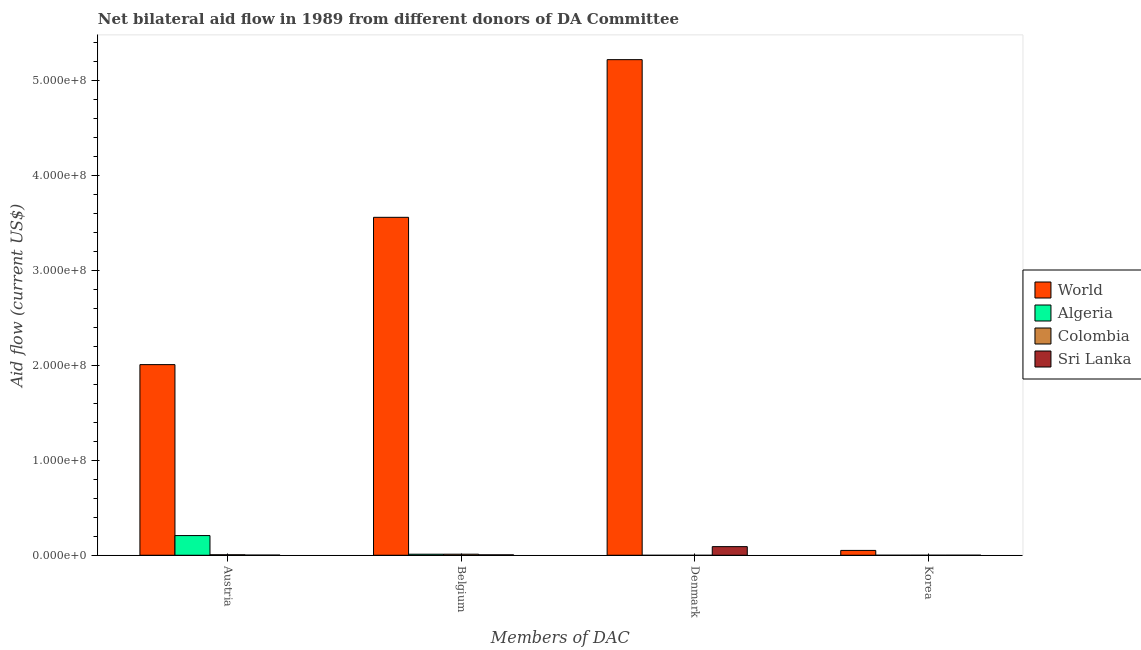How many groups of bars are there?
Offer a very short reply. 4. How many bars are there on the 2nd tick from the left?
Offer a terse response. 4. What is the label of the 4th group of bars from the left?
Make the answer very short. Korea. What is the amount of aid given by belgium in World?
Make the answer very short. 3.56e+08. Across all countries, what is the maximum amount of aid given by denmark?
Provide a short and direct response. 5.22e+08. Across all countries, what is the minimum amount of aid given by belgium?
Offer a terse response. 4.50e+05. In which country was the amount of aid given by denmark maximum?
Your answer should be very brief. World. What is the total amount of aid given by korea in the graph?
Your answer should be very brief. 5.18e+06. What is the difference between the amount of aid given by belgium in World and that in Sri Lanka?
Your answer should be very brief. 3.56e+08. What is the difference between the amount of aid given by korea in World and the amount of aid given by belgium in Colombia?
Make the answer very short. 3.98e+06. What is the average amount of aid given by belgium per country?
Give a very brief answer. 8.97e+07. What is the difference between the amount of aid given by korea and amount of aid given by austria in Algeria?
Provide a short and direct response. -2.07e+07. In how many countries, is the amount of aid given by denmark greater than 80000000 US$?
Your response must be concise. 1. What is the ratio of the amount of aid given by belgium in Algeria to that in Colombia?
Keep it short and to the point. 0.98. What is the difference between the highest and the second highest amount of aid given by austria?
Provide a succinct answer. 1.80e+08. What is the difference between the highest and the lowest amount of aid given by belgium?
Offer a very short reply. 3.56e+08. Is it the case that in every country, the sum of the amount of aid given by belgium and amount of aid given by austria is greater than the sum of amount of aid given by denmark and amount of aid given by korea?
Keep it short and to the point. No. Is it the case that in every country, the sum of the amount of aid given by austria and amount of aid given by belgium is greater than the amount of aid given by denmark?
Provide a short and direct response. No. Are all the bars in the graph horizontal?
Give a very brief answer. No. How are the legend labels stacked?
Provide a short and direct response. Vertical. What is the title of the graph?
Your answer should be compact. Net bilateral aid flow in 1989 from different donors of DA Committee. Does "Ecuador" appear as one of the legend labels in the graph?
Give a very brief answer. No. What is the label or title of the X-axis?
Offer a very short reply. Members of DAC. What is the Aid flow (current US$) of World in Austria?
Ensure brevity in your answer.  2.01e+08. What is the Aid flow (current US$) in Algeria in Austria?
Offer a terse response. 2.08e+07. What is the Aid flow (current US$) of Colombia in Austria?
Offer a very short reply. 5.30e+05. What is the Aid flow (current US$) in World in Belgium?
Offer a terse response. 3.56e+08. What is the Aid flow (current US$) in Algeria in Belgium?
Make the answer very short. 1.11e+06. What is the Aid flow (current US$) of Colombia in Belgium?
Your answer should be very brief. 1.13e+06. What is the Aid flow (current US$) in World in Denmark?
Ensure brevity in your answer.  5.22e+08. What is the Aid flow (current US$) of Sri Lanka in Denmark?
Make the answer very short. 9.10e+06. What is the Aid flow (current US$) in World in Korea?
Ensure brevity in your answer.  5.11e+06. Across all Members of DAC, what is the maximum Aid flow (current US$) of World?
Your answer should be very brief. 5.22e+08. Across all Members of DAC, what is the maximum Aid flow (current US$) of Algeria?
Offer a terse response. 2.08e+07. Across all Members of DAC, what is the maximum Aid flow (current US$) in Colombia?
Your answer should be very brief. 1.13e+06. Across all Members of DAC, what is the maximum Aid flow (current US$) in Sri Lanka?
Provide a succinct answer. 9.10e+06. Across all Members of DAC, what is the minimum Aid flow (current US$) of World?
Your answer should be compact. 5.11e+06. What is the total Aid flow (current US$) in World in the graph?
Your response must be concise. 1.08e+09. What is the total Aid flow (current US$) of Algeria in the graph?
Keep it short and to the point. 2.19e+07. What is the total Aid flow (current US$) in Colombia in the graph?
Offer a very short reply. 1.68e+06. What is the total Aid flow (current US$) in Sri Lanka in the graph?
Ensure brevity in your answer.  9.77e+06. What is the difference between the Aid flow (current US$) of World in Austria and that in Belgium?
Offer a very short reply. -1.55e+08. What is the difference between the Aid flow (current US$) of Algeria in Austria and that in Belgium?
Your answer should be compact. 1.96e+07. What is the difference between the Aid flow (current US$) of Colombia in Austria and that in Belgium?
Keep it short and to the point. -6.00e+05. What is the difference between the Aid flow (current US$) of World in Austria and that in Denmark?
Keep it short and to the point. -3.21e+08. What is the difference between the Aid flow (current US$) in Sri Lanka in Austria and that in Denmark?
Provide a short and direct response. -8.92e+06. What is the difference between the Aid flow (current US$) in World in Austria and that in Korea?
Offer a very short reply. 1.96e+08. What is the difference between the Aid flow (current US$) of Algeria in Austria and that in Korea?
Give a very brief answer. 2.07e+07. What is the difference between the Aid flow (current US$) in Colombia in Austria and that in Korea?
Give a very brief answer. 5.10e+05. What is the difference between the Aid flow (current US$) in World in Belgium and that in Denmark?
Your answer should be very brief. -1.66e+08. What is the difference between the Aid flow (current US$) of Sri Lanka in Belgium and that in Denmark?
Offer a terse response. -8.65e+06. What is the difference between the Aid flow (current US$) of World in Belgium and that in Korea?
Offer a terse response. 3.51e+08. What is the difference between the Aid flow (current US$) in Algeria in Belgium and that in Korea?
Your response must be concise. 1.10e+06. What is the difference between the Aid flow (current US$) in Colombia in Belgium and that in Korea?
Make the answer very short. 1.11e+06. What is the difference between the Aid flow (current US$) of World in Denmark and that in Korea?
Offer a terse response. 5.17e+08. What is the difference between the Aid flow (current US$) of Sri Lanka in Denmark and that in Korea?
Your answer should be very brief. 9.06e+06. What is the difference between the Aid flow (current US$) of World in Austria and the Aid flow (current US$) of Algeria in Belgium?
Offer a terse response. 2.00e+08. What is the difference between the Aid flow (current US$) of World in Austria and the Aid flow (current US$) of Colombia in Belgium?
Make the answer very short. 2.00e+08. What is the difference between the Aid flow (current US$) in World in Austria and the Aid flow (current US$) in Sri Lanka in Belgium?
Your response must be concise. 2.00e+08. What is the difference between the Aid flow (current US$) of Algeria in Austria and the Aid flow (current US$) of Colombia in Belgium?
Provide a succinct answer. 1.96e+07. What is the difference between the Aid flow (current US$) of Algeria in Austria and the Aid flow (current US$) of Sri Lanka in Belgium?
Offer a terse response. 2.03e+07. What is the difference between the Aid flow (current US$) in Colombia in Austria and the Aid flow (current US$) in Sri Lanka in Belgium?
Give a very brief answer. 8.00e+04. What is the difference between the Aid flow (current US$) in World in Austria and the Aid flow (current US$) in Sri Lanka in Denmark?
Your response must be concise. 1.92e+08. What is the difference between the Aid flow (current US$) in Algeria in Austria and the Aid flow (current US$) in Sri Lanka in Denmark?
Offer a terse response. 1.16e+07. What is the difference between the Aid flow (current US$) of Colombia in Austria and the Aid flow (current US$) of Sri Lanka in Denmark?
Offer a terse response. -8.57e+06. What is the difference between the Aid flow (current US$) of World in Austria and the Aid flow (current US$) of Algeria in Korea?
Make the answer very short. 2.01e+08. What is the difference between the Aid flow (current US$) in World in Austria and the Aid flow (current US$) in Colombia in Korea?
Provide a short and direct response. 2.01e+08. What is the difference between the Aid flow (current US$) in World in Austria and the Aid flow (current US$) in Sri Lanka in Korea?
Offer a terse response. 2.01e+08. What is the difference between the Aid flow (current US$) in Algeria in Austria and the Aid flow (current US$) in Colombia in Korea?
Provide a succinct answer. 2.07e+07. What is the difference between the Aid flow (current US$) in Algeria in Austria and the Aid flow (current US$) in Sri Lanka in Korea?
Your response must be concise. 2.07e+07. What is the difference between the Aid flow (current US$) in World in Belgium and the Aid flow (current US$) in Sri Lanka in Denmark?
Give a very brief answer. 3.47e+08. What is the difference between the Aid flow (current US$) in Algeria in Belgium and the Aid flow (current US$) in Sri Lanka in Denmark?
Make the answer very short. -7.99e+06. What is the difference between the Aid flow (current US$) of Colombia in Belgium and the Aid flow (current US$) of Sri Lanka in Denmark?
Offer a very short reply. -7.97e+06. What is the difference between the Aid flow (current US$) of World in Belgium and the Aid flow (current US$) of Algeria in Korea?
Keep it short and to the point. 3.56e+08. What is the difference between the Aid flow (current US$) in World in Belgium and the Aid flow (current US$) in Colombia in Korea?
Make the answer very short. 3.56e+08. What is the difference between the Aid flow (current US$) in World in Belgium and the Aid flow (current US$) in Sri Lanka in Korea?
Your answer should be compact. 3.56e+08. What is the difference between the Aid flow (current US$) in Algeria in Belgium and the Aid flow (current US$) in Colombia in Korea?
Give a very brief answer. 1.09e+06. What is the difference between the Aid flow (current US$) of Algeria in Belgium and the Aid flow (current US$) of Sri Lanka in Korea?
Ensure brevity in your answer.  1.07e+06. What is the difference between the Aid flow (current US$) of Colombia in Belgium and the Aid flow (current US$) of Sri Lanka in Korea?
Your response must be concise. 1.09e+06. What is the difference between the Aid flow (current US$) in World in Denmark and the Aid flow (current US$) in Algeria in Korea?
Your answer should be compact. 5.22e+08. What is the difference between the Aid flow (current US$) of World in Denmark and the Aid flow (current US$) of Colombia in Korea?
Your response must be concise. 5.22e+08. What is the difference between the Aid flow (current US$) in World in Denmark and the Aid flow (current US$) in Sri Lanka in Korea?
Make the answer very short. 5.22e+08. What is the average Aid flow (current US$) in World per Members of DAC?
Give a very brief answer. 2.71e+08. What is the average Aid flow (current US$) in Algeria per Members of DAC?
Your answer should be very brief. 5.47e+06. What is the average Aid flow (current US$) of Colombia per Members of DAC?
Your answer should be compact. 4.20e+05. What is the average Aid flow (current US$) in Sri Lanka per Members of DAC?
Offer a very short reply. 2.44e+06. What is the difference between the Aid flow (current US$) in World and Aid flow (current US$) in Algeria in Austria?
Offer a very short reply. 1.80e+08. What is the difference between the Aid flow (current US$) of World and Aid flow (current US$) of Colombia in Austria?
Ensure brevity in your answer.  2.00e+08. What is the difference between the Aid flow (current US$) in World and Aid flow (current US$) in Sri Lanka in Austria?
Give a very brief answer. 2.01e+08. What is the difference between the Aid flow (current US$) of Algeria and Aid flow (current US$) of Colombia in Austria?
Your answer should be very brief. 2.02e+07. What is the difference between the Aid flow (current US$) of Algeria and Aid flow (current US$) of Sri Lanka in Austria?
Ensure brevity in your answer.  2.06e+07. What is the difference between the Aid flow (current US$) of World and Aid flow (current US$) of Algeria in Belgium?
Ensure brevity in your answer.  3.55e+08. What is the difference between the Aid flow (current US$) in World and Aid flow (current US$) in Colombia in Belgium?
Give a very brief answer. 3.55e+08. What is the difference between the Aid flow (current US$) in World and Aid flow (current US$) in Sri Lanka in Belgium?
Make the answer very short. 3.56e+08. What is the difference between the Aid flow (current US$) of Colombia and Aid flow (current US$) of Sri Lanka in Belgium?
Provide a short and direct response. 6.80e+05. What is the difference between the Aid flow (current US$) of World and Aid flow (current US$) of Sri Lanka in Denmark?
Give a very brief answer. 5.13e+08. What is the difference between the Aid flow (current US$) of World and Aid flow (current US$) of Algeria in Korea?
Make the answer very short. 5.10e+06. What is the difference between the Aid flow (current US$) of World and Aid flow (current US$) of Colombia in Korea?
Keep it short and to the point. 5.09e+06. What is the difference between the Aid flow (current US$) of World and Aid flow (current US$) of Sri Lanka in Korea?
Your response must be concise. 5.07e+06. What is the difference between the Aid flow (current US$) of Algeria and Aid flow (current US$) of Colombia in Korea?
Your answer should be compact. -10000. What is the ratio of the Aid flow (current US$) in World in Austria to that in Belgium?
Your answer should be very brief. 0.56. What is the ratio of the Aid flow (current US$) in Algeria in Austria to that in Belgium?
Provide a short and direct response. 18.69. What is the ratio of the Aid flow (current US$) in Colombia in Austria to that in Belgium?
Your response must be concise. 0.47. What is the ratio of the Aid flow (current US$) of Sri Lanka in Austria to that in Belgium?
Your response must be concise. 0.4. What is the ratio of the Aid flow (current US$) in World in Austria to that in Denmark?
Ensure brevity in your answer.  0.38. What is the ratio of the Aid flow (current US$) in Sri Lanka in Austria to that in Denmark?
Provide a short and direct response. 0.02. What is the ratio of the Aid flow (current US$) in World in Austria to that in Korea?
Your answer should be very brief. 39.32. What is the ratio of the Aid flow (current US$) in Algeria in Austria to that in Korea?
Offer a terse response. 2075. What is the ratio of the Aid flow (current US$) of Colombia in Austria to that in Korea?
Keep it short and to the point. 26.5. What is the ratio of the Aid flow (current US$) of World in Belgium to that in Denmark?
Your answer should be compact. 0.68. What is the ratio of the Aid flow (current US$) in Sri Lanka in Belgium to that in Denmark?
Offer a very short reply. 0.05. What is the ratio of the Aid flow (current US$) in World in Belgium to that in Korea?
Your answer should be very brief. 69.7. What is the ratio of the Aid flow (current US$) in Algeria in Belgium to that in Korea?
Your answer should be compact. 111. What is the ratio of the Aid flow (current US$) in Colombia in Belgium to that in Korea?
Provide a short and direct response. 56.5. What is the ratio of the Aid flow (current US$) of Sri Lanka in Belgium to that in Korea?
Give a very brief answer. 11.25. What is the ratio of the Aid flow (current US$) in World in Denmark to that in Korea?
Ensure brevity in your answer.  102.22. What is the ratio of the Aid flow (current US$) in Sri Lanka in Denmark to that in Korea?
Offer a very short reply. 227.5. What is the difference between the highest and the second highest Aid flow (current US$) of World?
Give a very brief answer. 1.66e+08. What is the difference between the highest and the second highest Aid flow (current US$) in Algeria?
Your answer should be very brief. 1.96e+07. What is the difference between the highest and the second highest Aid flow (current US$) in Sri Lanka?
Make the answer very short. 8.65e+06. What is the difference between the highest and the lowest Aid flow (current US$) of World?
Your answer should be very brief. 5.17e+08. What is the difference between the highest and the lowest Aid flow (current US$) in Algeria?
Your answer should be compact. 2.08e+07. What is the difference between the highest and the lowest Aid flow (current US$) in Colombia?
Ensure brevity in your answer.  1.13e+06. What is the difference between the highest and the lowest Aid flow (current US$) in Sri Lanka?
Make the answer very short. 9.06e+06. 